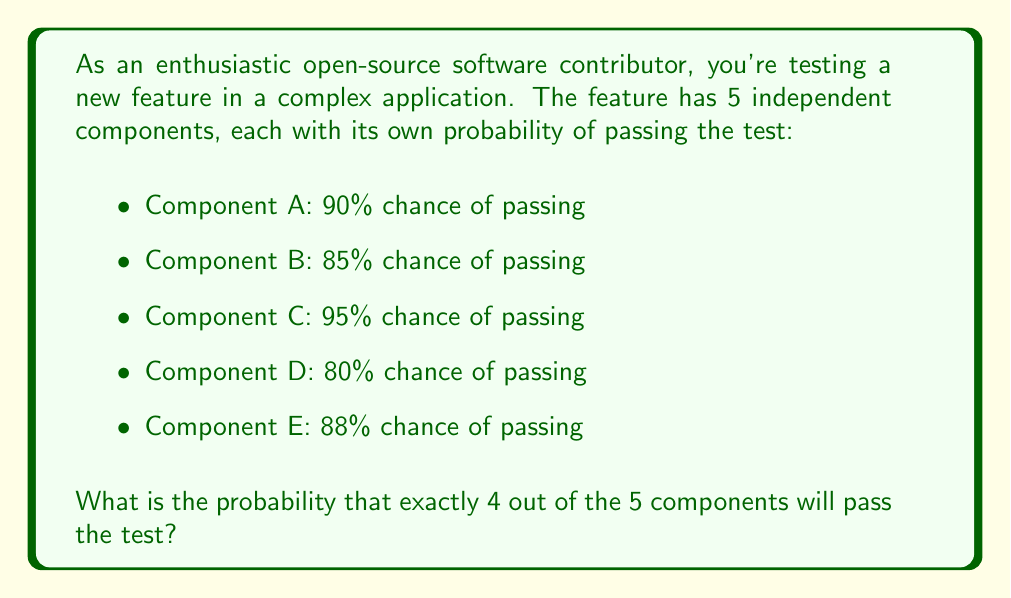Could you help me with this problem? To solve this problem, we'll use the concept of binomial probability. We need to calculate the probability of exactly 4 successes in 5 trials, where each trial has a different probability of success.

1) First, let's calculate the probability of failure for each component:
   A: $1 - 0.90 = 0.10$
   B: $1 - 0.85 = 0.15$
   C: $1 - 0.95 = 0.05$
   D: $1 - 0.80 = 0.20$
   E: $1 - 0.88 = 0.12$

2) Now, we need to consider all possible combinations where exactly 4 components pass. There are 5 such combinations:
   ABCD, ABCE, ABDE, ACDE, BCDE

3) Let's calculate the probability for each combination:

   ABCD: $0.90 \times 0.85 \times 0.95 \times 0.80 \times 0.12 = 0.06962$
   ABCE: $0.90 \times 0.85 \times 0.95 \times 0.20 \times 0.88 = 0.12760$
   ABDE: $0.90 \times 0.85 \times 0.05 \times 0.80 \times 0.88 = 0.02698$
   ACDE: $0.90 \times 0.15 \times 0.95 \times 0.80 \times 0.88 = 0.09029$
   BCDE: $0.10 \times 0.85 \times 0.95 \times 0.80 \times 0.88 = 0.05675$

4) The total probability is the sum of these individual probabilities:

   $$P(\text{exactly 4 passing}) = 0.06962 + 0.12760 + 0.02698 + 0.09029 + 0.05675 = 0.37124$$

Therefore, the probability that exactly 4 out of the 5 components will pass the test is approximately 0.37124 or 37.124%.
Answer: $0.37124$ or $37.124\%$ 